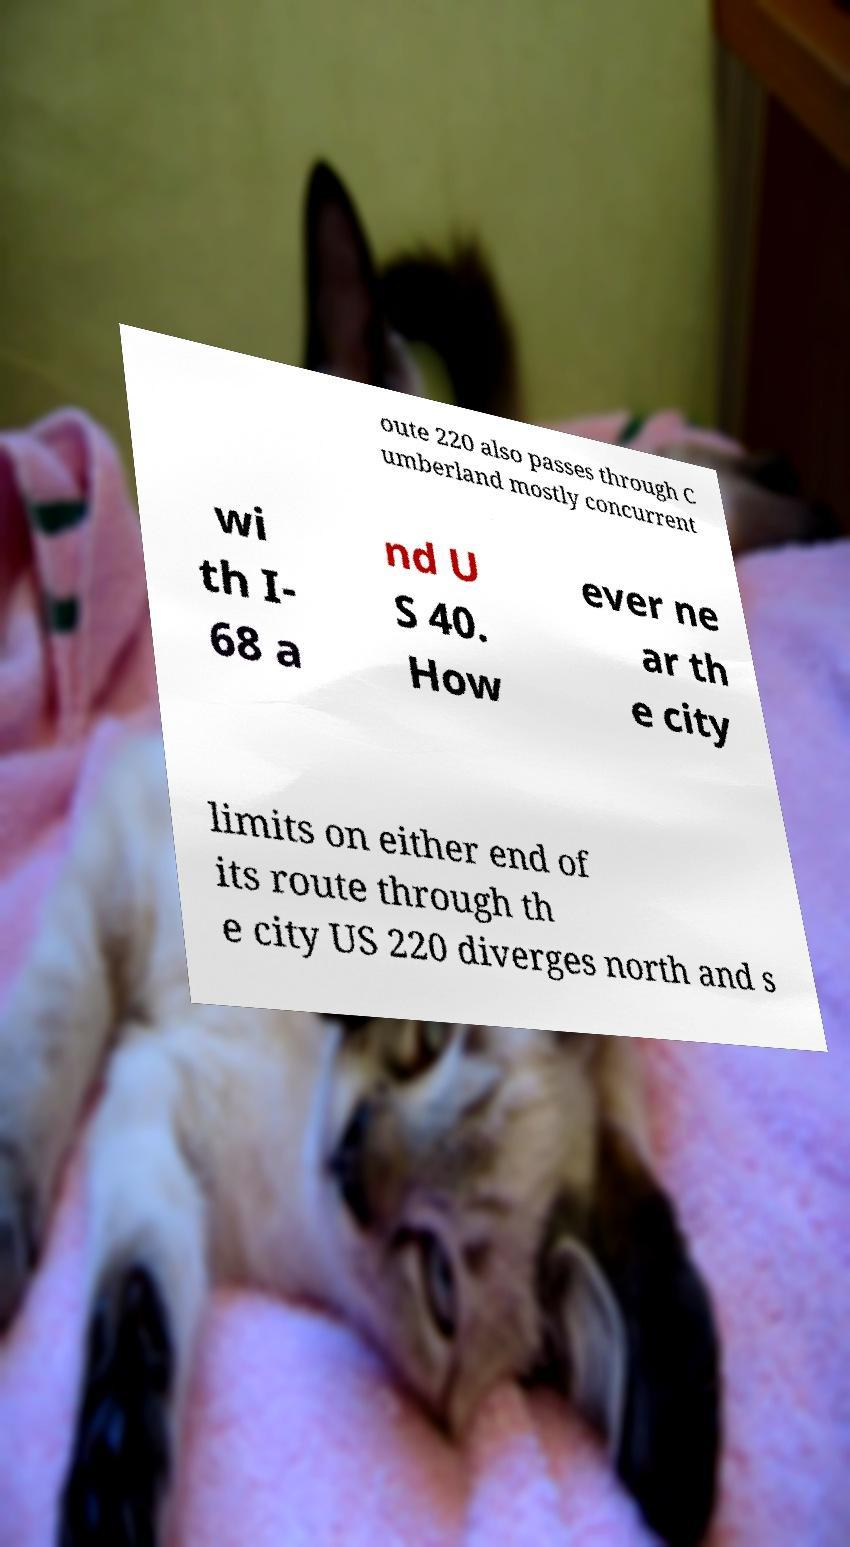There's text embedded in this image that I need extracted. Can you transcribe it verbatim? oute 220 also passes through C umberland mostly concurrent wi th I- 68 a nd U S 40. How ever ne ar th e city limits on either end of its route through th e city US 220 diverges north and s 